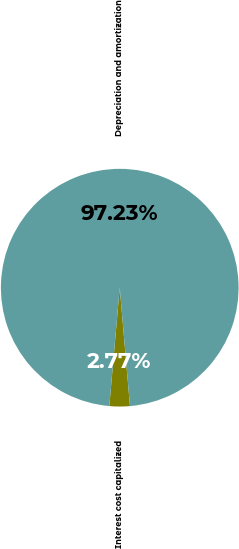Convert chart. <chart><loc_0><loc_0><loc_500><loc_500><pie_chart><fcel>Interest cost capitalized<fcel>Depreciation and amortization<nl><fcel>2.77%<fcel>97.23%<nl></chart> 